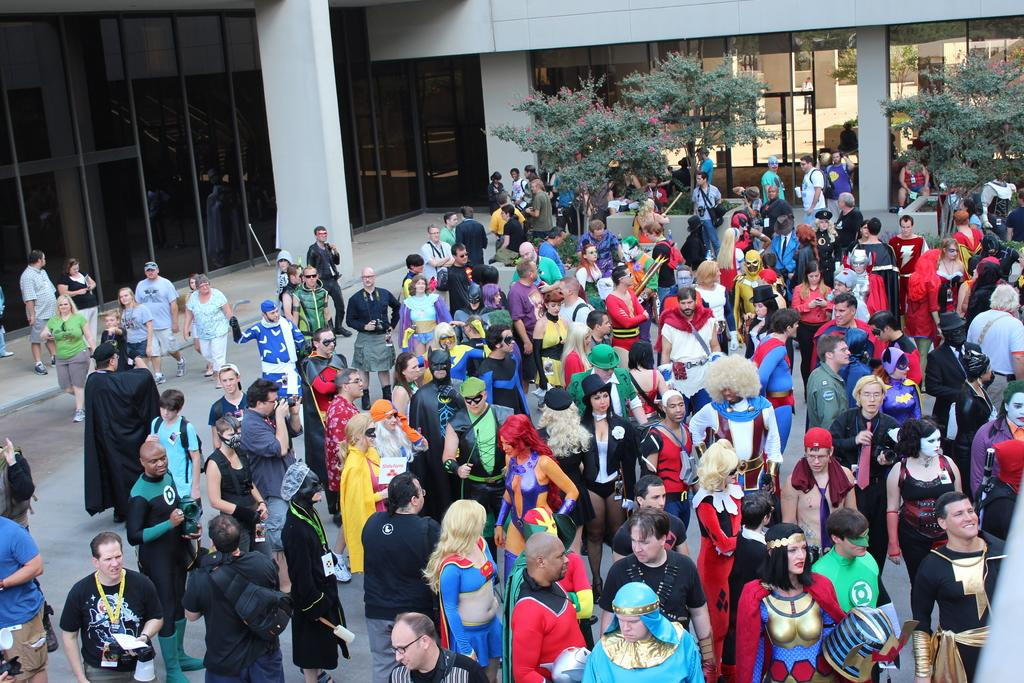What can be seen in the image? There are groups of people in the image. What are some people wearing? Some people are in fancy dress. What is visible in the background of the image? There are trees and a building in the background of the image. How many ants can be seen on the mask in the image? There is no mask or ants present in the image. What type of heart is visible on the tree in the image? There is no heart visible on the tree in the image. 